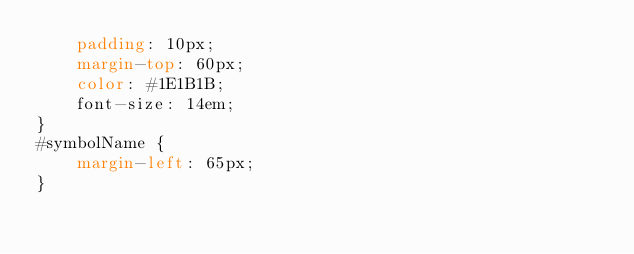Convert code to text. <code><loc_0><loc_0><loc_500><loc_500><_CSS_>    padding: 10px;
    margin-top: 60px;
    color: #1E1B1B;
    font-size: 14em;
}
#symbolName {
    margin-left: 65px;
}
</code> 